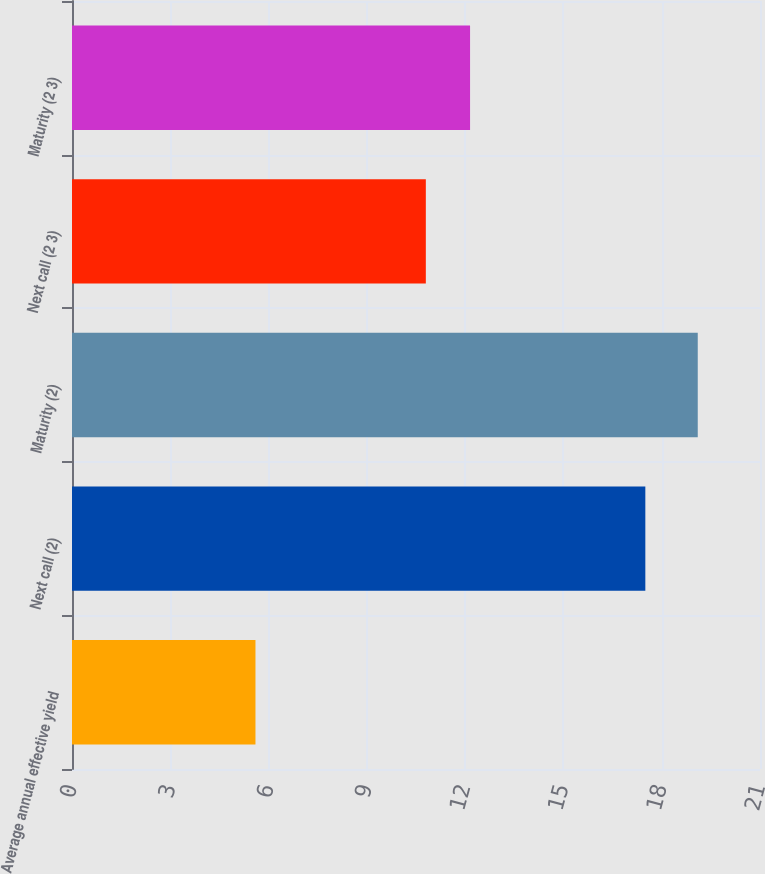Convert chart to OTSL. <chart><loc_0><loc_0><loc_500><loc_500><bar_chart><fcel>Average annual effective yield<fcel>Next call (2)<fcel>Maturity (2)<fcel>Next call (2 3)<fcel>Maturity (2 3)<nl><fcel>5.6<fcel>17.5<fcel>19.1<fcel>10.8<fcel>12.15<nl></chart> 